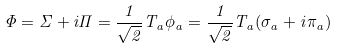Convert formula to latex. <formula><loc_0><loc_0><loc_500><loc_500>\Phi = \Sigma + i \Pi = \frac { 1 } { \sqrt { 2 } } T _ { a } \phi _ { a } = \frac { 1 } { \sqrt { 2 } } T _ { a } ( \sigma _ { a } + i \pi _ { a } )</formula> 